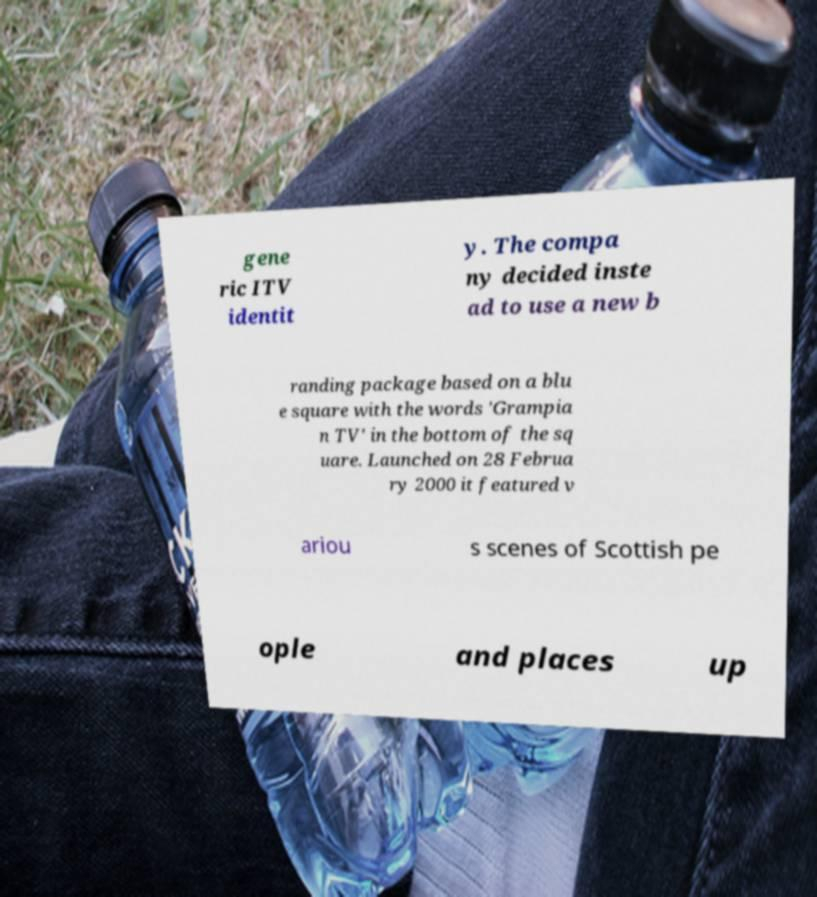Could you assist in decoding the text presented in this image and type it out clearly? gene ric ITV identit y. The compa ny decided inste ad to use a new b randing package based on a blu e square with the words 'Grampia n TV' in the bottom of the sq uare. Launched on 28 Februa ry 2000 it featured v ariou s scenes of Scottish pe ople and places up 